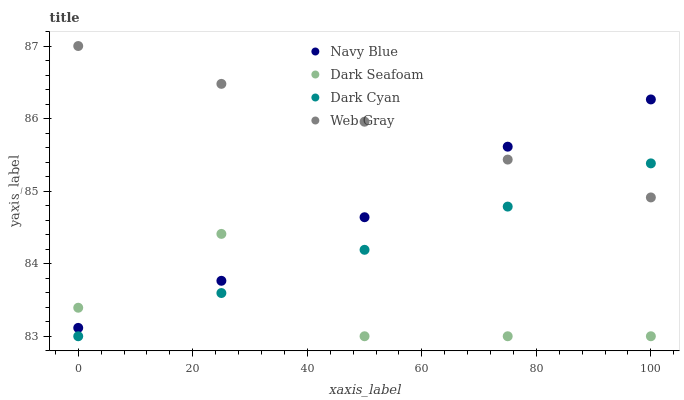Does Dark Seafoam have the minimum area under the curve?
Answer yes or no. Yes. Does Web Gray have the maximum area under the curve?
Answer yes or no. Yes. Does Navy Blue have the minimum area under the curve?
Answer yes or no. No. Does Navy Blue have the maximum area under the curve?
Answer yes or no. No. Is Dark Cyan the smoothest?
Answer yes or no. Yes. Is Dark Seafoam the roughest?
Answer yes or no. Yes. Is Navy Blue the smoothest?
Answer yes or no. No. Is Navy Blue the roughest?
Answer yes or no. No. Does Dark Cyan have the lowest value?
Answer yes or no. Yes. Does Navy Blue have the lowest value?
Answer yes or no. No. Does Web Gray have the highest value?
Answer yes or no. Yes. Does Navy Blue have the highest value?
Answer yes or no. No. Is Dark Cyan less than Navy Blue?
Answer yes or no. Yes. Is Web Gray greater than Dark Seafoam?
Answer yes or no. Yes. Does Navy Blue intersect Dark Seafoam?
Answer yes or no. Yes. Is Navy Blue less than Dark Seafoam?
Answer yes or no. No. Is Navy Blue greater than Dark Seafoam?
Answer yes or no. No. Does Dark Cyan intersect Navy Blue?
Answer yes or no. No. 